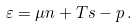<formula> <loc_0><loc_0><loc_500><loc_500>\varepsilon = \mu n + T s - p \, .</formula> 